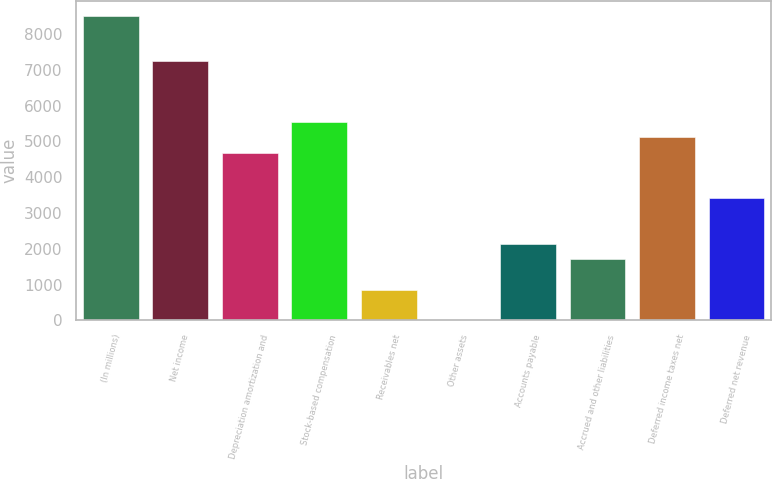Convert chart. <chart><loc_0><loc_0><loc_500><loc_500><bar_chart><fcel>(In millions)<fcel>Net income<fcel>Depreciation amortization and<fcel>Stock-based compensation<fcel>Receivables net<fcel>Other assets<fcel>Accounts payable<fcel>Accrued and other liabilities<fcel>Deferred income taxes net<fcel>Deferred net revenue<nl><fcel>8506<fcel>7231.6<fcel>4682.8<fcel>5532.4<fcel>859.6<fcel>10<fcel>2134<fcel>1709.2<fcel>5107.6<fcel>3408.4<nl></chart> 